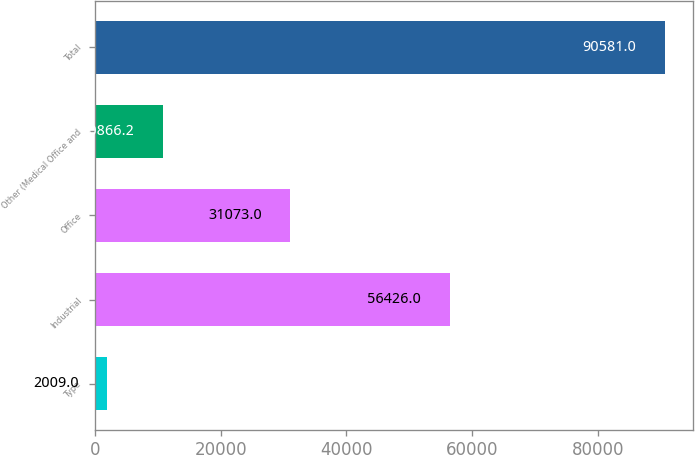Convert chart. <chart><loc_0><loc_0><loc_500><loc_500><bar_chart><fcel>Type<fcel>Industrial<fcel>Office<fcel>Other (Medical Office and<fcel>Total<nl><fcel>2009<fcel>56426<fcel>31073<fcel>10866.2<fcel>90581<nl></chart> 